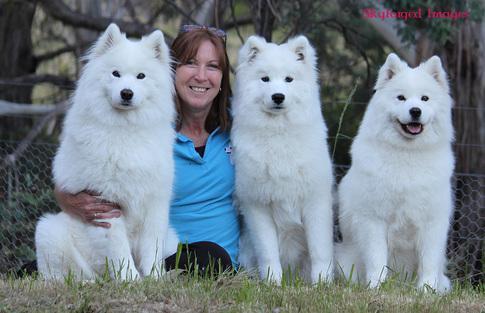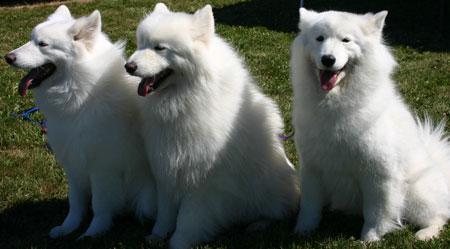The first image is the image on the left, the second image is the image on the right. For the images shown, is this caption "An image shows a trio of side-by-side white puppies on green grass, facing forward with not all paws on the ground." true? Answer yes or no. No. The first image is the image on the left, the second image is the image on the right. Examine the images to the left and right. Is the description "The left image shows a woman next to no less than one white dog" accurate? Answer yes or no. Yes. 